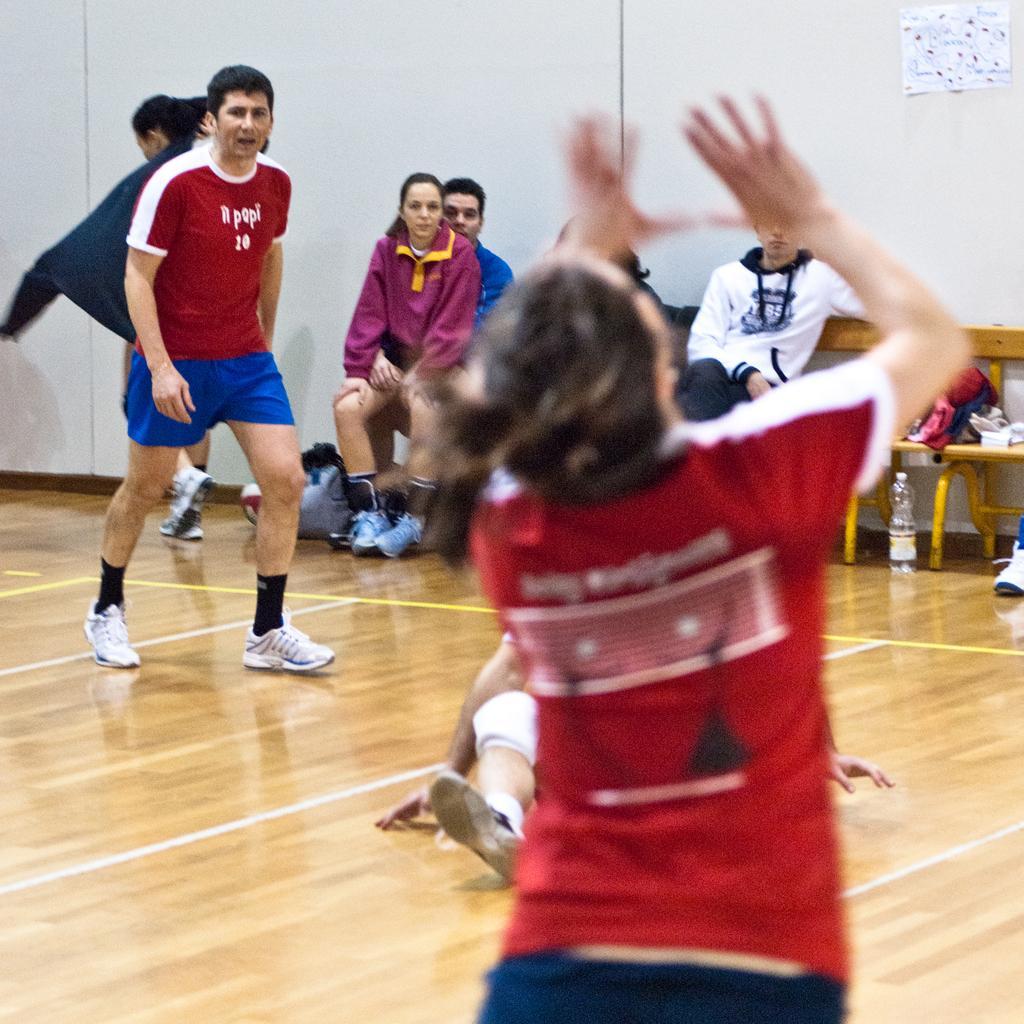Can you describe this image briefly? In the picture we can see a wooden floor play hall with some people playing and wearing a sports wear, in the background, we can see some people are sitting on the bench near the wall which is white in color and some paper pasted to it. 